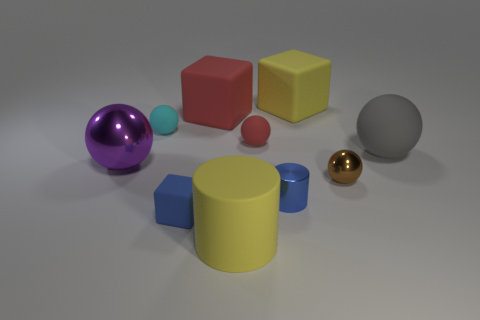Subtract all metallic spheres. How many spheres are left? 3 Subtract 1 cylinders. How many cylinders are left? 1 Subtract all brown spheres. How many spheres are left? 4 Subtract all cubes. How many objects are left? 7 Add 4 blue matte cubes. How many blue matte cubes exist? 5 Subtract 0 brown cubes. How many objects are left? 10 Subtract all blue cylinders. Subtract all blue cubes. How many cylinders are left? 1 Subtract all large purple metal spheres. Subtract all cyan balls. How many objects are left? 8 Add 3 yellow things. How many yellow things are left? 5 